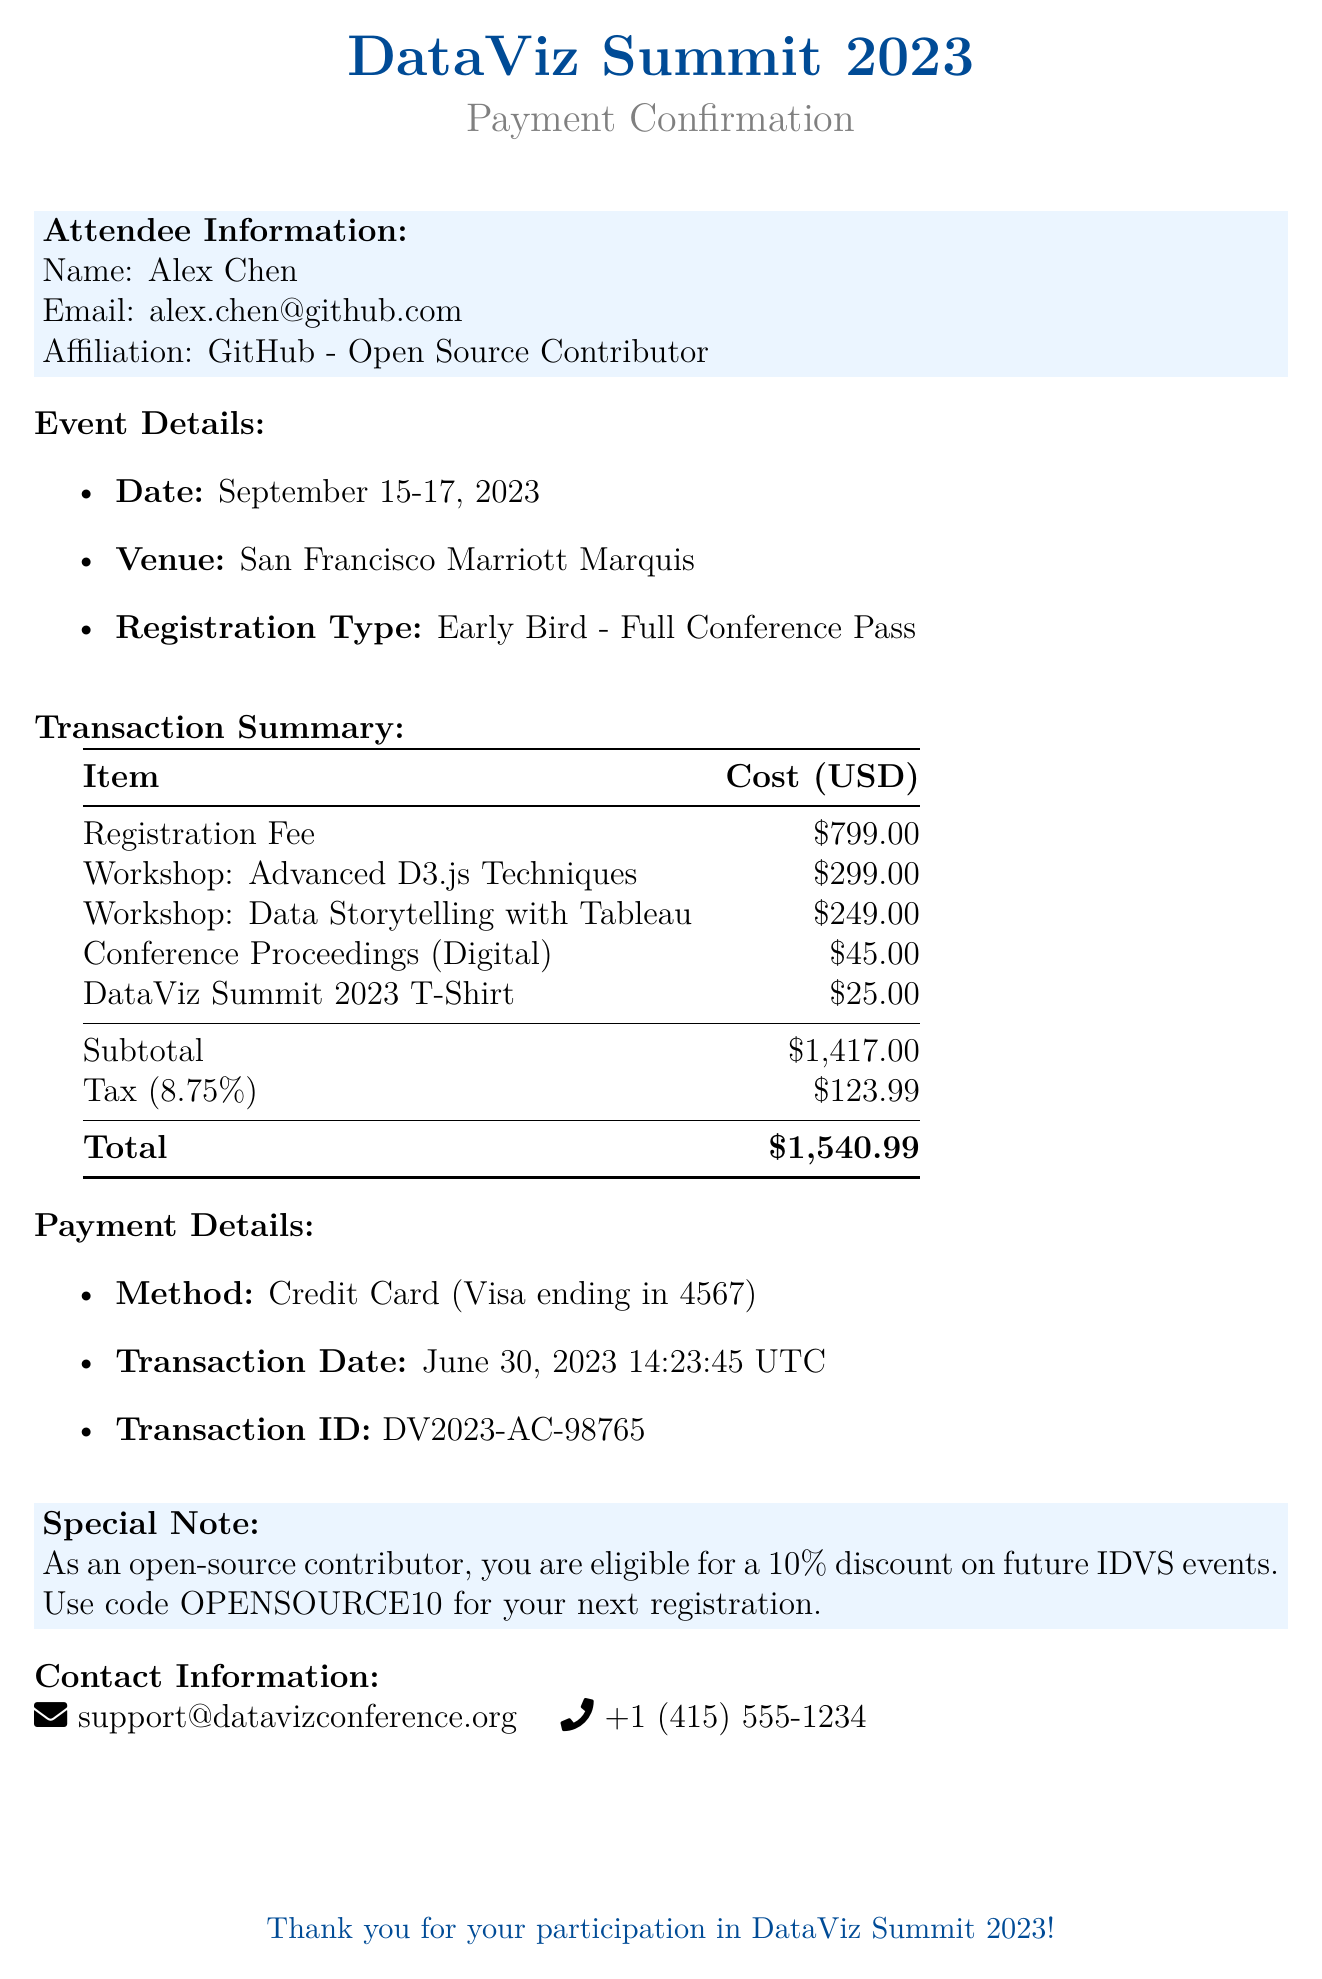What is the name of the conference? The document states that the conference is called "DataViz Summit 2023."
Answer: DataViz Summit 2023 Who is the organizer of the event? According to the document, the event is organized by the "International Data Visualization Society."
Answer: International Data Visualization Society What is the registration fee for the conference? The document lists the registration fee as $799.00.
Answer: $799.00 How much does the workshop on Advanced D3.js Techniques cost? The cost of the Advanced D3.js Techniques workshop is specified as $299.00 in the document.
Answer: $299.00 What is the total amount paid for the conference attendance? The total amount for the conference, including fees and additional items, is $1540.99 as stated in the document.
Answer: $1540.99 How many days does the conference span? The document indicates that the event takes place over three days.
Answer: Three days What is the tax rate applied to the transaction? The document mentions a tax rate of 8.75%.
Answer: 8.75% What is the transaction ID for this payment? The transaction ID provided in the document is "DV2023-AC-98765."
Answer: DV2023-AC-98765 What special note is mentioned for open-source contributors? The document includes a note stating that open-source contributors can use the code OPENSOURCE10 for a 10% discount on future registrations.
Answer: Use code OPENSOURCE10 for your next registration 